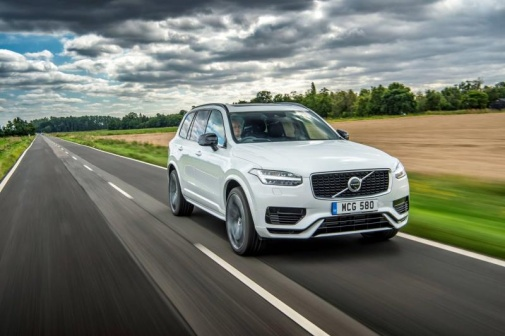Describe a potential road trip experience in this car. Picture yourself on an unforgettable road trip in this Volvo XC90. The adventure begins with a gentle rain shower that leaves the road glistening as you drive through lush, green countryside. The seats are comfortable, and the advanced technologies of the car keep you connected and entertained. The panoramic sunroof lets in natural light, enhancing the serene beauty of the surrounding landscape. As the clouds part and a rainbow appears, you make a stop at a charming, rustic café for a warm cup of coffee, breathing in the fresh, crisp air. Continuing your journey, you explore hidden trails and picturesque villages, creating lifelong memories on this rejuvenating escape. 